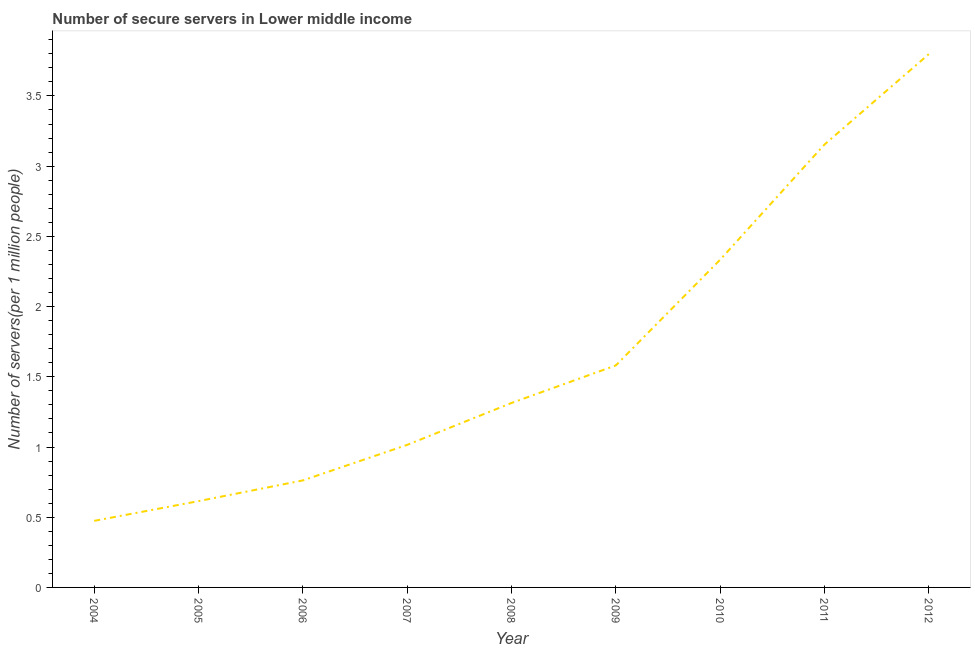What is the number of secure internet servers in 2012?
Your answer should be very brief. 3.8. Across all years, what is the maximum number of secure internet servers?
Your answer should be very brief. 3.8. Across all years, what is the minimum number of secure internet servers?
Make the answer very short. 0.47. In which year was the number of secure internet servers maximum?
Your answer should be compact. 2012. In which year was the number of secure internet servers minimum?
Give a very brief answer. 2004. What is the sum of the number of secure internet servers?
Ensure brevity in your answer.  15.05. What is the difference between the number of secure internet servers in 2006 and 2011?
Your answer should be very brief. -2.39. What is the average number of secure internet servers per year?
Give a very brief answer. 1.67. What is the median number of secure internet servers?
Give a very brief answer. 1.31. In how many years, is the number of secure internet servers greater than 1.2 ?
Give a very brief answer. 5. Do a majority of the years between 2004 and 2011 (inclusive) have number of secure internet servers greater than 3.3 ?
Your answer should be very brief. No. What is the ratio of the number of secure internet servers in 2008 to that in 2012?
Provide a short and direct response. 0.35. What is the difference between the highest and the second highest number of secure internet servers?
Your response must be concise. 0.64. What is the difference between the highest and the lowest number of secure internet servers?
Offer a terse response. 3.32. How many lines are there?
Ensure brevity in your answer.  1. Does the graph contain any zero values?
Make the answer very short. No. Does the graph contain grids?
Provide a succinct answer. No. What is the title of the graph?
Offer a terse response. Number of secure servers in Lower middle income. What is the label or title of the Y-axis?
Your answer should be very brief. Number of servers(per 1 million people). What is the Number of servers(per 1 million people) of 2004?
Give a very brief answer. 0.47. What is the Number of servers(per 1 million people) in 2005?
Offer a very short reply. 0.61. What is the Number of servers(per 1 million people) in 2006?
Give a very brief answer. 0.76. What is the Number of servers(per 1 million people) in 2007?
Offer a terse response. 1.02. What is the Number of servers(per 1 million people) in 2008?
Your answer should be compact. 1.31. What is the Number of servers(per 1 million people) in 2009?
Give a very brief answer. 1.58. What is the Number of servers(per 1 million people) of 2010?
Offer a terse response. 2.33. What is the Number of servers(per 1 million people) in 2011?
Your response must be concise. 3.15. What is the Number of servers(per 1 million people) in 2012?
Provide a succinct answer. 3.8. What is the difference between the Number of servers(per 1 million people) in 2004 and 2005?
Make the answer very short. -0.14. What is the difference between the Number of servers(per 1 million people) in 2004 and 2006?
Your answer should be very brief. -0.29. What is the difference between the Number of servers(per 1 million people) in 2004 and 2007?
Offer a terse response. -0.54. What is the difference between the Number of servers(per 1 million people) in 2004 and 2008?
Give a very brief answer. -0.84. What is the difference between the Number of servers(per 1 million people) in 2004 and 2009?
Your answer should be compact. -1.11. What is the difference between the Number of servers(per 1 million people) in 2004 and 2010?
Your response must be concise. -1.86. What is the difference between the Number of servers(per 1 million people) in 2004 and 2011?
Make the answer very short. -2.68. What is the difference between the Number of servers(per 1 million people) in 2004 and 2012?
Your answer should be very brief. -3.32. What is the difference between the Number of servers(per 1 million people) in 2005 and 2006?
Make the answer very short. -0.15. What is the difference between the Number of servers(per 1 million people) in 2005 and 2007?
Ensure brevity in your answer.  -0.4. What is the difference between the Number of servers(per 1 million people) in 2005 and 2008?
Your response must be concise. -0.7. What is the difference between the Number of servers(per 1 million people) in 2005 and 2009?
Your answer should be compact. -0.97. What is the difference between the Number of servers(per 1 million people) in 2005 and 2010?
Ensure brevity in your answer.  -1.72. What is the difference between the Number of servers(per 1 million people) in 2005 and 2011?
Keep it short and to the point. -2.54. What is the difference between the Number of servers(per 1 million people) in 2005 and 2012?
Make the answer very short. -3.18. What is the difference between the Number of servers(per 1 million people) in 2006 and 2007?
Provide a succinct answer. -0.25. What is the difference between the Number of servers(per 1 million people) in 2006 and 2008?
Give a very brief answer. -0.55. What is the difference between the Number of servers(per 1 million people) in 2006 and 2009?
Your answer should be very brief. -0.82. What is the difference between the Number of servers(per 1 million people) in 2006 and 2010?
Your answer should be very brief. -1.57. What is the difference between the Number of servers(per 1 million people) in 2006 and 2011?
Provide a succinct answer. -2.39. What is the difference between the Number of servers(per 1 million people) in 2006 and 2012?
Keep it short and to the point. -3.04. What is the difference between the Number of servers(per 1 million people) in 2007 and 2008?
Your answer should be compact. -0.3. What is the difference between the Number of servers(per 1 million people) in 2007 and 2009?
Your answer should be very brief. -0.57. What is the difference between the Number of servers(per 1 million people) in 2007 and 2010?
Ensure brevity in your answer.  -1.32. What is the difference between the Number of servers(per 1 million people) in 2007 and 2011?
Offer a very short reply. -2.14. What is the difference between the Number of servers(per 1 million people) in 2007 and 2012?
Provide a succinct answer. -2.78. What is the difference between the Number of servers(per 1 million people) in 2008 and 2009?
Provide a short and direct response. -0.27. What is the difference between the Number of servers(per 1 million people) in 2008 and 2010?
Your answer should be compact. -1.02. What is the difference between the Number of servers(per 1 million people) in 2008 and 2011?
Keep it short and to the point. -1.84. What is the difference between the Number of servers(per 1 million people) in 2008 and 2012?
Your answer should be very brief. -2.48. What is the difference between the Number of servers(per 1 million people) in 2009 and 2010?
Your answer should be very brief. -0.75. What is the difference between the Number of servers(per 1 million people) in 2009 and 2011?
Give a very brief answer. -1.57. What is the difference between the Number of servers(per 1 million people) in 2009 and 2012?
Your answer should be compact. -2.22. What is the difference between the Number of servers(per 1 million people) in 2010 and 2011?
Provide a short and direct response. -0.82. What is the difference between the Number of servers(per 1 million people) in 2010 and 2012?
Keep it short and to the point. -1.46. What is the difference between the Number of servers(per 1 million people) in 2011 and 2012?
Ensure brevity in your answer.  -0.64. What is the ratio of the Number of servers(per 1 million people) in 2004 to that in 2005?
Your answer should be very brief. 0.77. What is the ratio of the Number of servers(per 1 million people) in 2004 to that in 2006?
Keep it short and to the point. 0.62. What is the ratio of the Number of servers(per 1 million people) in 2004 to that in 2007?
Offer a terse response. 0.47. What is the ratio of the Number of servers(per 1 million people) in 2004 to that in 2008?
Make the answer very short. 0.36. What is the ratio of the Number of servers(per 1 million people) in 2004 to that in 2010?
Ensure brevity in your answer.  0.2. What is the ratio of the Number of servers(per 1 million people) in 2004 to that in 2012?
Keep it short and to the point. 0.12. What is the ratio of the Number of servers(per 1 million people) in 2005 to that in 2006?
Your answer should be very brief. 0.81. What is the ratio of the Number of servers(per 1 million people) in 2005 to that in 2007?
Keep it short and to the point. 0.6. What is the ratio of the Number of servers(per 1 million people) in 2005 to that in 2008?
Ensure brevity in your answer.  0.47. What is the ratio of the Number of servers(per 1 million people) in 2005 to that in 2009?
Your answer should be very brief. 0.39. What is the ratio of the Number of servers(per 1 million people) in 2005 to that in 2010?
Offer a very short reply. 0.26. What is the ratio of the Number of servers(per 1 million people) in 2005 to that in 2011?
Keep it short and to the point. 0.2. What is the ratio of the Number of servers(per 1 million people) in 2005 to that in 2012?
Ensure brevity in your answer.  0.16. What is the ratio of the Number of servers(per 1 million people) in 2006 to that in 2007?
Make the answer very short. 0.75. What is the ratio of the Number of servers(per 1 million people) in 2006 to that in 2008?
Provide a succinct answer. 0.58. What is the ratio of the Number of servers(per 1 million people) in 2006 to that in 2009?
Make the answer very short. 0.48. What is the ratio of the Number of servers(per 1 million people) in 2006 to that in 2010?
Provide a succinct answer. 0.33. What is the ratio of the Number of servers(per 1 million people) in 2006 to that in 2011?
Ensure brevity in your answer.  0.24. What is the ratio of the Number of servers(per 1 million people) in 2006 to that in 2012?
Provide a succinct answer. 0.2. What is the ratio of the Number of servers(per 1 million people) in 2007 to that in 2008?
Ensure brevity in your answer.  0.77. What is the ratio of the Number of servers(per 1 million people) in 2007 to that in 2009?
Ensure brevity in your answer.  0.64. What is the ratio of the Number of servers(per 1 million people) in 2007 to that in 2010?
Your answer should be very brief. 0.43. What is the ratio of the Number of servers(per 1 million people) in 2007 to that in 2011?
Your response must be concise. 0.32. What is the ratio of the Number of servers(per 1 million people) in 2007 to that in 2012?
Provide a short and direct response. 0.27. What is the ratio of the Number of servers(per 1 million people) in 2008 to that in 2009?
Ensure brevity in your answer.  0.83. What is the ratio of the Number of servers(per 1 million people) in 2008 to that in 2010?
Make the answer very short. 0.56. What is the ratio of the Number of servers(per 1 million people) in 2008 to that in 2011?
Your answer should be compact. 0.42. What is the ratio of the Number of servers(per 1 million people) in 2008 to that in 2012?
Offer a terse response. 0.35. What is the ratio of the Number of servers(per 1 million people) in 2009 to that in 2010?
Give a very brief answer. 0.68. What is the ratio of the Number of servers(per 1 million people) in 2009 to that in 2011?
Your answer should be compact. 0.5. What is the ratio of the Number of servers(per 1 million people) in 2009 to that in 2012?
Make the answer very short. 0.42. What is the ratio of the Number of servers(per 1 million people) in 2010 to that in 2011?
Ensure brevity in your answer.  0.74. What is the ratio of the Number of servers(per 1 million people) in 2010 to that in 2012?
Offer a very short reply. 0.61. What is the ratio of the Number of servers(per 1 million people) in 2011 to that in 2012?
Provide a short and direct response. 0.83. 